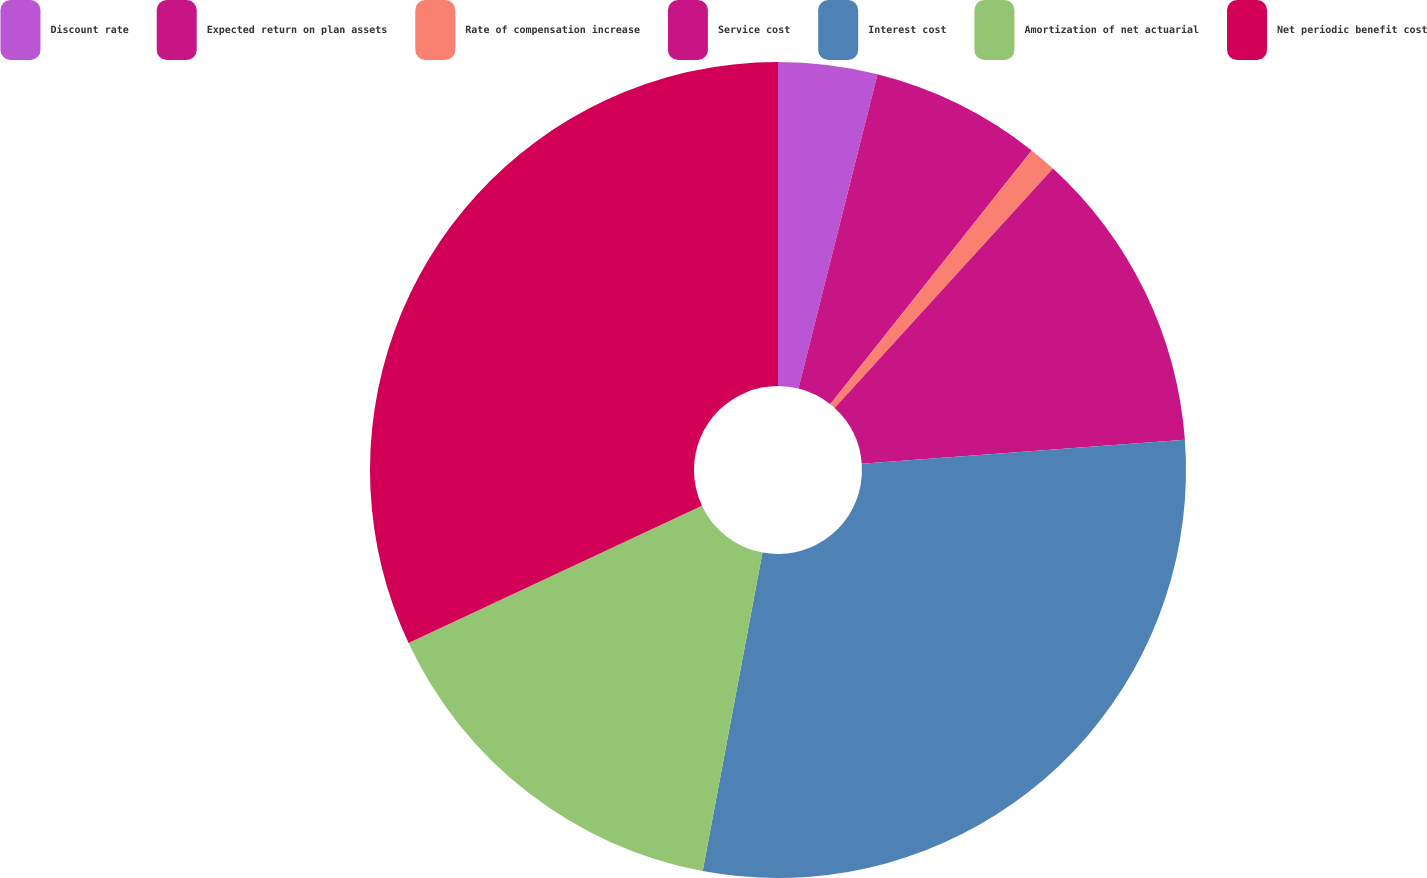<chart> <loc_0><loc_0><loc_500><loc_500><pie_chart><fcel>Discount rate<fcel>Expected return on plan assets<fcel>Rate of compensation increase<fcel>Service cost<fcel>Interest cost<fcel>Amortization of net actuarial<fcel>Net periodic benefit cost<nl><fcel>3.92%<fcel>6.76%<fcel>1.09%<fcel>12.05%<fcel>29.13%<fcel>15.07%<fcel>31.97%<nl></chart> 